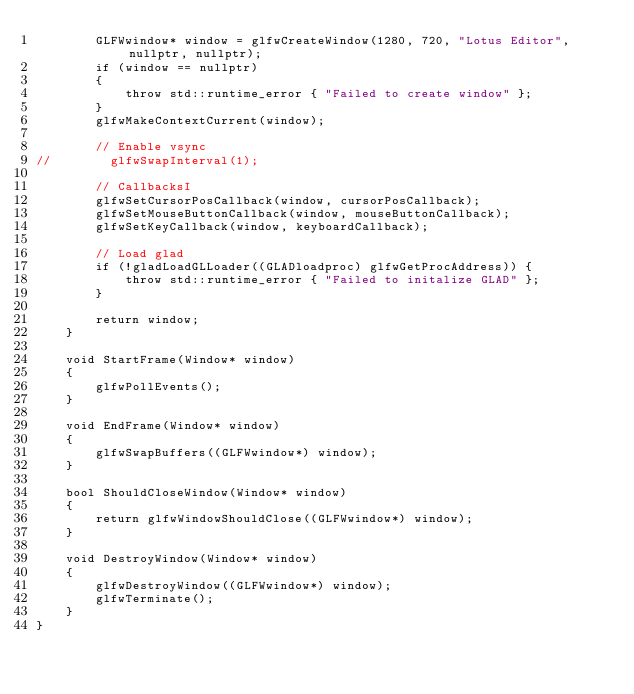Convert code to text. <code><loc_0><loc_0><loc_500><loc_500><_C++_>        GLFWwindow* window = glfwCreateWindow(1280, 720, "Lotus Editor", nullptr, nullptr);
        if (window == nullptr)
        {
            throw std::runtime_error { "Failed to create window" };
        }
        glfwMakeContextCurrent(window);

        // Enable vsync
//        glfwSwapInterval(1);

        // CallbacksI
        glfwSetCursorPosCallback(window, cursorPosCallback);
        glfwSetMouseButtonCallback(window, mouseButtonCallback);
        glfwSetKeyCallback(window, keyboardCallback);

        // Load glad
        if (!gladLoadGLLoader((GLADloadproc) glfwGetProcAddress)) {
            throw std::runtime_error { "Failed to initalize GLAD" };
        }

        return window;
    }

    void StartFrame(Window* window)
    {
        glfwPollEvents();
    }

    void EndFrame(Window* window)
    {
        glfwSwapBuffers((GLFWwindow*) window);
    }

    bool ShouldCloseWindow(Window* window)
    {
        return glfwWindowShouldClose((GLFWwindow*) window);
    }

    void DestroyWindow(Window* window)
    {
        glfwDestroyWindow((GLFWwindow*) window);
        glfwTerminate();
    }
}
</code> 